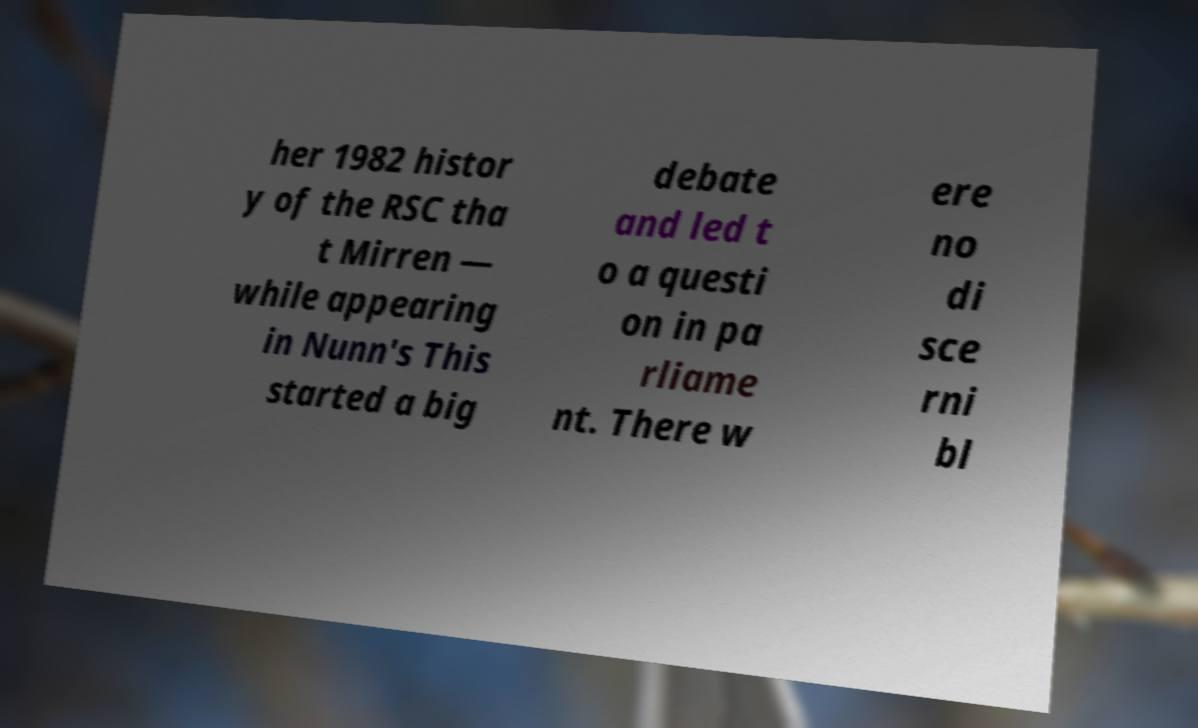Please read and relay the text visible in this image. What does it say? her 1982 histor y of the RSC tha t Mirren — while appearing in Nunn's This started a big debate and led t o a questi on in pa rliame nt. There w ere no di sce rni bl 